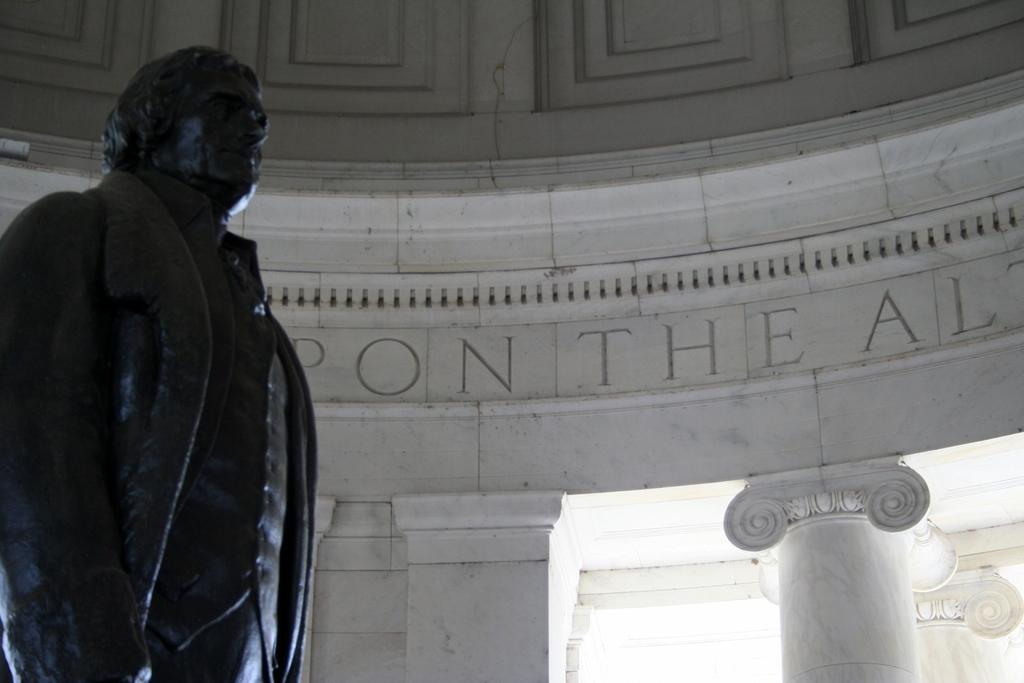What is located on the left side of the image? There is a statue on the left side of the image. What can be seen in the background of the image? There is a wall and a pillar in the background of the image. Can you tell me where your aunt is sitting in the image? There is no reference to an aunt or any person sitting in the image; it only features a statue and a background with a wall and a pillar. 